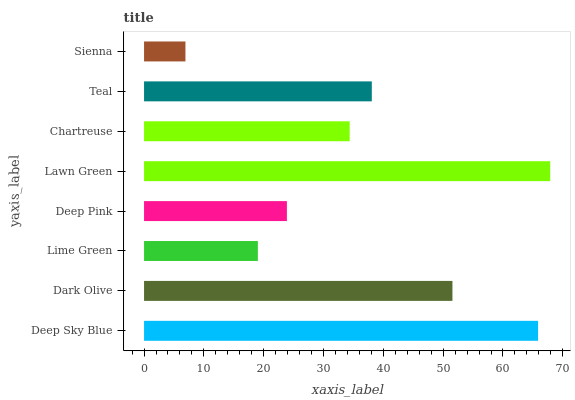Is Sienna the minimum?
Answer yes or no. Yes. Is Lawn Green the maximum?
Answer yes or no. Yes. Is Dark Olive the minimum?
Answer yes or no. No. Is Dark Olive the maximum?
Answer yes or no. No. Is Deep Sky Blue greater than Dark Olive?
Answer yes or no. Yes. Is Dark Olive less than Deep Sky Blue?
Answer yes or no. Yes. Is Dark Olive greater than Deep Sky Blue?
Answer yes or no. No. Is Deep Sky Blue less than Dark Olive?
Answer yes or no. No. Is Teal the high median?
Answer yes or no. Yes. Is Chartreuse the low median?
Answer yes or no. Yes. Is Lime Green the high median?
Answer yes or no. No. Is Deep Pink the low median?
Answer yes or no. No. 